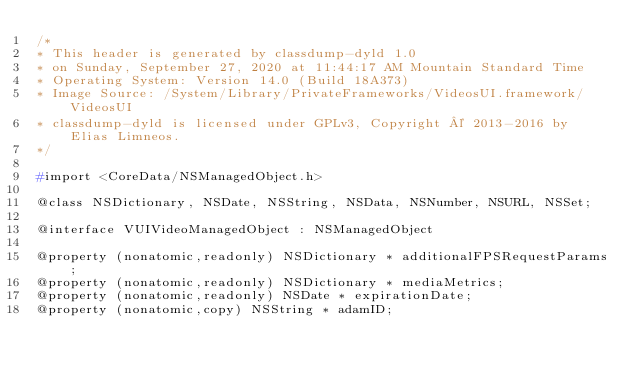<code> <loc_0><loc_0><loc_500><loc_500><_C_>/*
* This header is generated by classdump-dyld 1.0
* on Sunday, September 27, 2020 at 11:44:17 AM Mountain Standard Time
* Operating System: Version 14.0 (Build 18A373)
* Image Source: /System/Library/PrivateFrameworks/VideosUI.framework/VideosUI
* classdump-dyld is licensed under GPLv3, Copyright © 2013-2016 by Elias Limneos.
*/

#import <CoreData/NSManagedObject.h>

@class NSDictionary, NSDate, NSString, NSData, NSNumber, NSURL, NSSet;

@interface VUIVideoManagedObject : NSManagedObject

@property (nonatomic,readonly) NSDictionary * additionalFPSRequestParams; 
@property (nonatomic,readonly) NSDictionary * mediaMetrics; 
@property (nonatomic,readonly) NSDate * expirationDate; 
@property (nonatomic,copy) NSString * adamID; </code> 